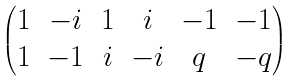Convert formula to latex. <formula><loc_0><loc_0><loc_500><loc_500>\begin{pmatrix} 1 & - i & 1 & i & - 1 & - 1 \\ 1 & - 1 & i & - i & q & - q \end{pmatrix}</formula> 